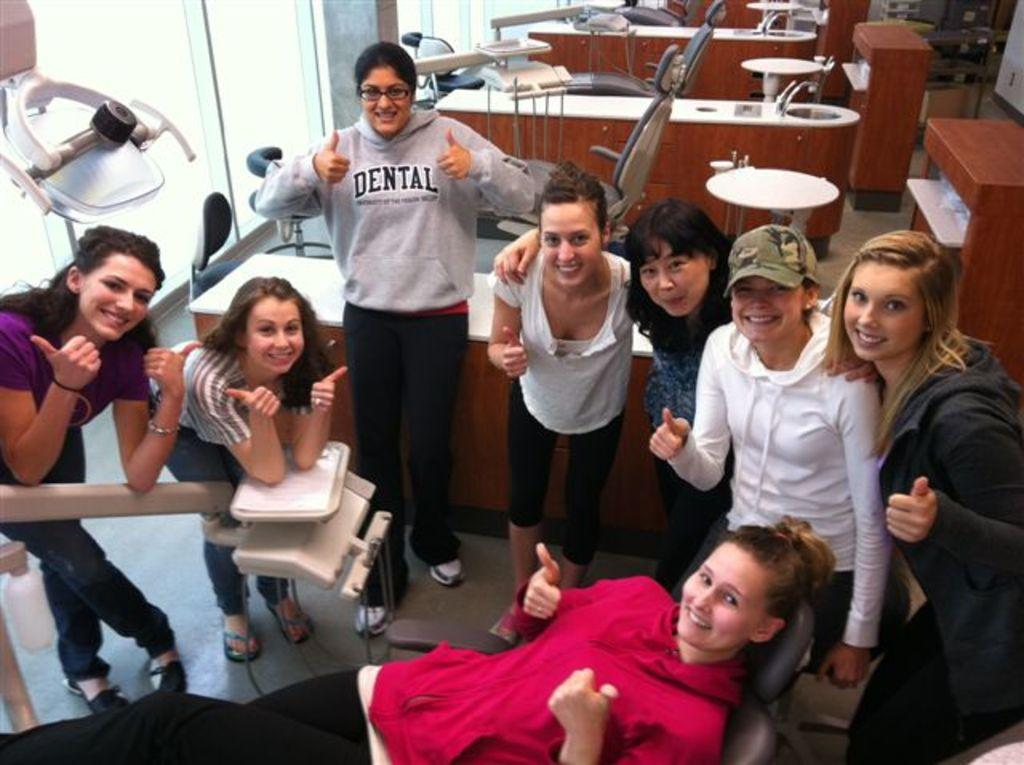What are the women in the room doing? There are women standing in the room, and one woman is lying on a chair. Can you describe the furniture in the background of the image? There are chairs and tables in the background of the image. What type of monkey can be seen climbing on the chair in the image? There is no monkey present in the image; it only features women standing and lying on chairs. 